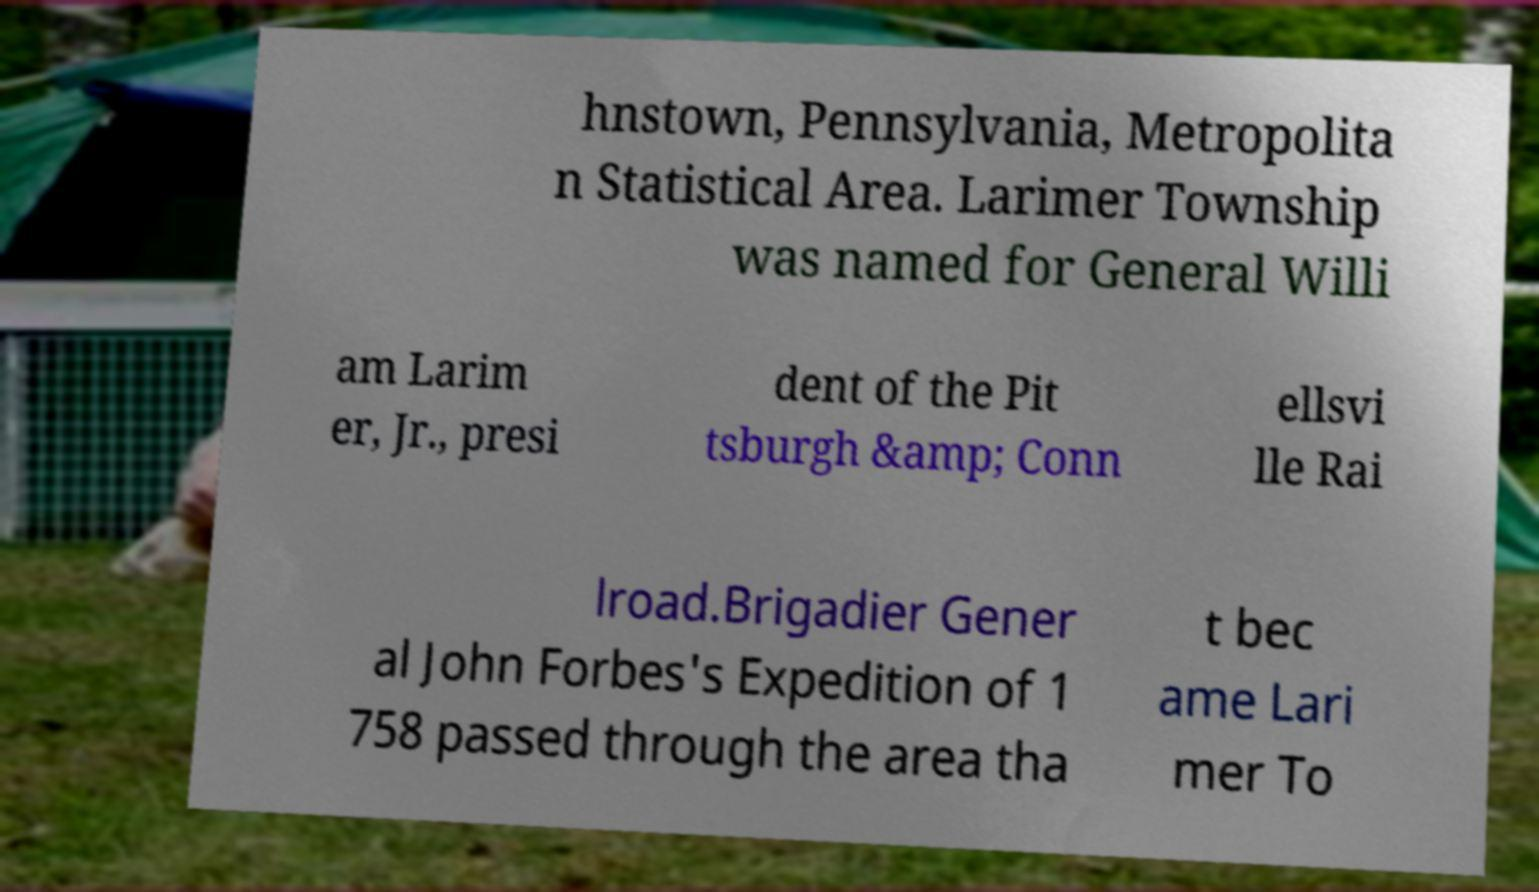For documentation purposes, I need the text within this image transcribed. Could you provide that? hnstown, Pennsylvania, Metropolita n Statistical Area. Larimer Township was named for General Willi am Larim er, Jr., presi dent of the Pit tsburgh &amp; Conn ellsvi lle Rai lroad.Brigadier Gener al John Forbes's Expedition of 1 758 passed through the area tha t bec ame Lari mer To 